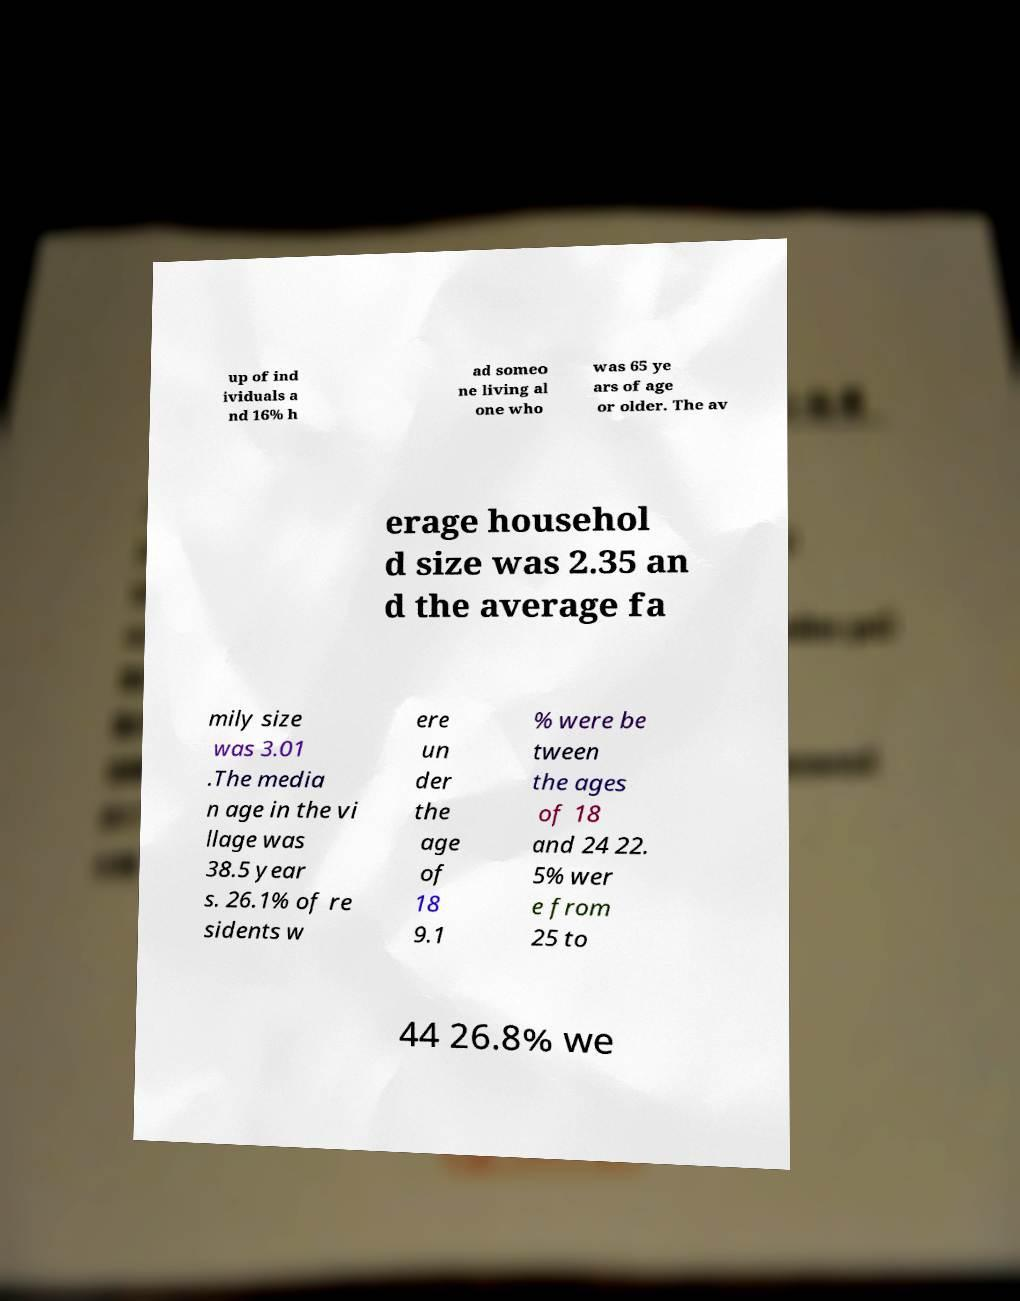Please read and relay the text visible in this image. What does it say? up of ind ividuals a nd 16% h ad someo ne living al one who was 65 ye ars of age or older. The av erage househol d size was 2.35 an d the average fa mily size was 3.01 .The media n age in the vi llage was 38.5 year s. 26.1% of re sidents w ere un der the age of 18 9.1 % were be tween the ages of 18 and 24 22. 5% wer e from 25 to 44 26.8% we 